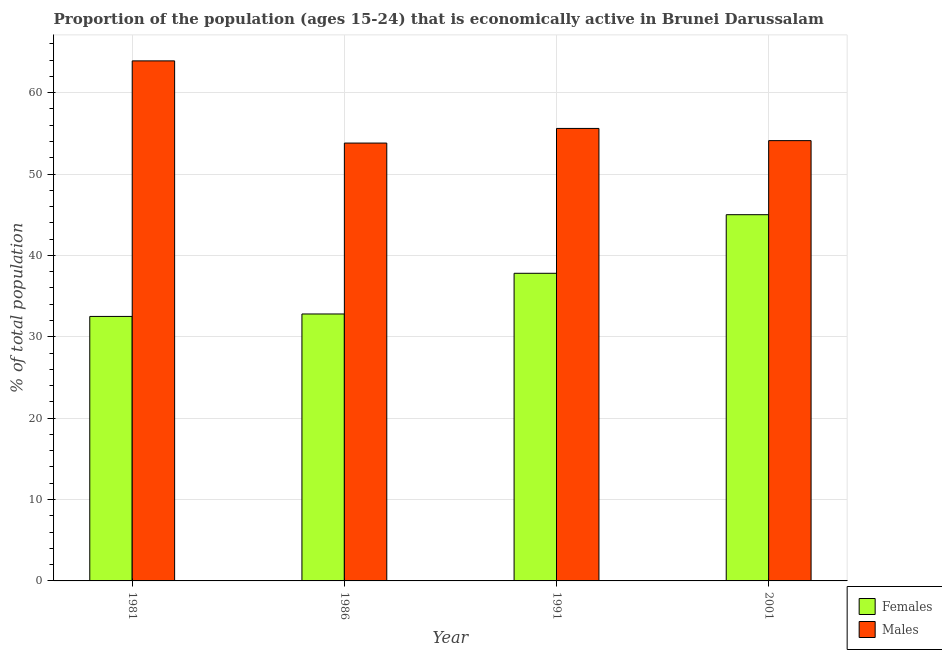How many different coloured bars are there?
Offer a terse response. 2. How many bars are there on the 2nd tick from the left?
Your answer should be compact. 2. How many bars are there on the 2nd tick from the right?
Give a very brief answer. 2. What is the label of the 4th group of bars from the left?
Give a very brief answer. 2001. In how many cases, is the number of bars for a given year not equal to the number of legend labels?
Provide a short and direct response. 0. What is the percentage of economically active male population in 2001?
Your answer should be very brief. 54.1. Across all years, what is the maximum percentage of economically active male population?
Ensure brevity in your answer.  63.9. Across all years, what is the minimum percentage of economically active male population?
Keep it short and to the point. 53.8. In which year was the percentage of economically active female population maximum?
Provide a succinct answer. 2001. What is the total percentage of economically active male population in the graph?
Provide a succinct answer. 227.4. What is the difference between the percentage of economically active female population in 1981 and that in 2001?
Your response must be concise. -12.5. What is the difference between the percentage of economically active female population in 1986 and the percentage of economically active male population in 1981?
Provide a short and direct response. 0.3. What is the average percentage of economically active male population per year?
Offer a very short reply. 56.85. In how many years, is the percentage of economically active male population greater than 48 %?
Offer a terse response. 4. What is the ratio of the percentage of economically active male population in 1986 to that in 1991?
Your answer should be very brief. 0.97. Is the percentage of economically active female population in 1981 less than that in 1986?
Offer a very short reply. Yes. Is the difference between the percentage of economically active female population in 1986 and 1991 greater than the difference between the percentage of economically active male population in 1986 and 1991?
Provide a short and direct response. No. What is the difference between the highest and the second highest percentage of economically active female population?
Your answer should be very brief. 7.2. What is the difference between the highest and the lowest percentage of economically active male population?
Your answer should be very brief. 10.1. What does the 1st bar from the left in 2001 represents?
Give a very brief answer. Females. What does the 2nd bar from the right in 1981 represents?
Provide a succinct answer. Females. How many years are there in the graph?
Provide a short and direct response. 4. Are the values on the major ticks of Y-axis written in scientific E-notation?
Ensure brevity in your answer.  No. Does the graph contain grids?
Provide a short and direct response. Yes. Where does the legend appear in the graph?
Your answer should be compact. Bottom right. How are the legend labels stacked?
Provide a short and direct response. Vertical. What is the title of the graph?
Your answer should be compact. Proportion of the population (ages 15-24) that is economically active in Brunei Darussalam. Does "Residents" appear as one of the legend labels in the graph?
Your answer should be very brief. No. What is the label or title of the X-axis?
Offer a very short reply. Year. What is the label or title of the Y-axis?
Provide a short and direct response. % of total population. What is the % of total population of Females in 1981?
Provide a succinct answer. 32.5. What is the % of total population in Males in 1981?
Make the answer very short. 63.9. What is the % of total population in Females in 1986?
Provide a succinct answer. 32.8. What is the % of total population in Males in 1986?
Ensure brevity in your answer.  53.8. What is the % of total population in Females in 1991?
Give a very brief answer. 37.8. What is the % of total population of Males in 1991?
Your answer should be very brief. 55.6. What is the % of total population of Females in 2001?
Keep it short and to the point. 45. What is the % of total population in Males in 2001?
Your answer should be compact. 54.1. Across all years, what is the maximum % of total population in Females?
Your answer should be very brief. 45. Across all years, what is the maximum % of total population in Males?
Your answer should be compact. 63.9. Across all years, what is the minimum % of total population of Females?
Your response must be concise. 32.5. Across all years, what is the minimum % of total population of Males?
Provide a short and direct response. 53.8. What is the total % of total population in Females in the graph?
Keep it short and to the point. 148.1. What is the total % of total population in Males in the graph?
Make the answer very short. 227.4. What is the difference between the % of total population in Females in 1981 and that in 1986?
Give a very brief answer. -0.3. What is the difference between the % of total population in Males in 1981 and that in 1991?
Offer a very short reply. 8.3. What is the difference between the % of total population in Males in 1986 and that in 1991?
Keep it short and to the point. -1.8. What is the difference between the % of total population in Males in 1986 and that in 2001?
Make the answer very short. -0.3. What is the difference between the % of total population of Females in 1981 and the % of total population of Males in 1986?
Offer a terse response. -21.3. What is the difference between the % of total population of Females in 1981 and the % of total population of Males in 1991?
Offer a terse response. -23.1. What is the difference between the % of total population in Females in 1981 and the % of total population in Males in 2001?
Offer a terse response. -21.6. What is the difference between the % of total population in Females in 1986 and the % of total population in Males in 1991?
Ensure brevity in your answer.  -22.8. What is the difference between the % of total population in Females in 1986 and the % of total population in Males in 2001?
Provide a short and direct response. -21.3. What is the difference between the % of total population in Females in 1991 and the % of total population in Males in 2001?
Your answer should be very brief. -16.3. What is the average % of total population in Females per year?
Offer a terse response. 37.02. What is the average % of total population in Males per year?
Ensure brevity in your answer.  56.85. In the year 1981, what is the difference between the % of total population of Females and % of total population of Males?
Offer a terse response. -31.4. In the year 1991, what is the difference between the % of total population of Females and % of total population of Males?
Ensure brevity in your answer.  -17.8. What is the ratio of the % of total population in Females in 1981 to that in 1986?
Give a very brief answer. 0.99. What is the ratio of the % of total population of Males in 1981 to that in 1986?
Provide a succinct answer. 1.19. What is the ratio of the % of total population of Females in 1981 to that in 1991?
Your answer should be compact. 0.86. What is the ratio of the % of total population in Males in 1981 to that in 1991?
Your answer should be compact. 1.15. What is the ratio of the % of total population in Females in 1981 to that in 2001?
Your response must be concise. 0.72. What is the ratio of the % of total population in Males in 1981 to that in 2001?
Ensure brevity in your answer.  1.18. What is the ratio of the % of total population of Females in 1986 to that in 1991?
Keep it short and to the point. 0.87. What is the ratio of the % of total population in Males in 1986 to that in 1991?
Give a very brief answer. 0.97. What is the ratio of the % of total population of Females in 1986 to that in 2001?
Your response must be concise. 0.73. What is the ratio of the % of total population of Males in 1986 to that in 2001?
Provide a succinct answer. 0.99. What is the ratio of the % of total population of Females in 1991 to that in 2001?
Keep it short and to the point. 0.84. What is the ratio of the % of total population of Males in 1991 to that in 2001?
Your answer should be compact. 1.03. What is the difference between the highest and the lowest % of total population in Males?
Give a very brief answer. 10.1. 